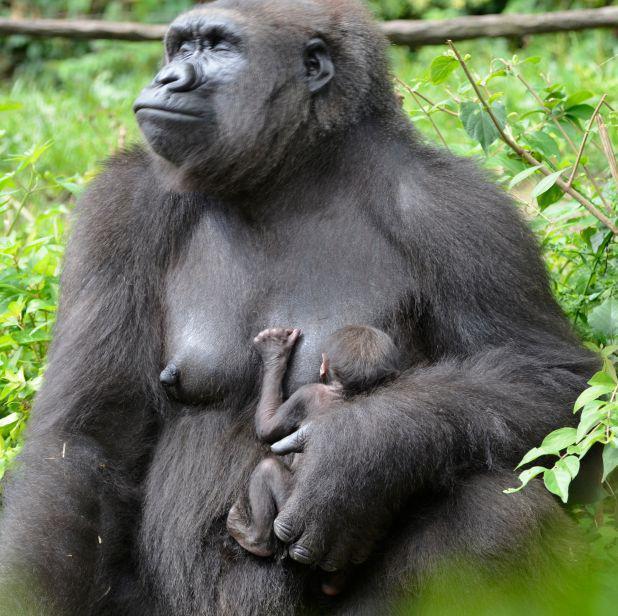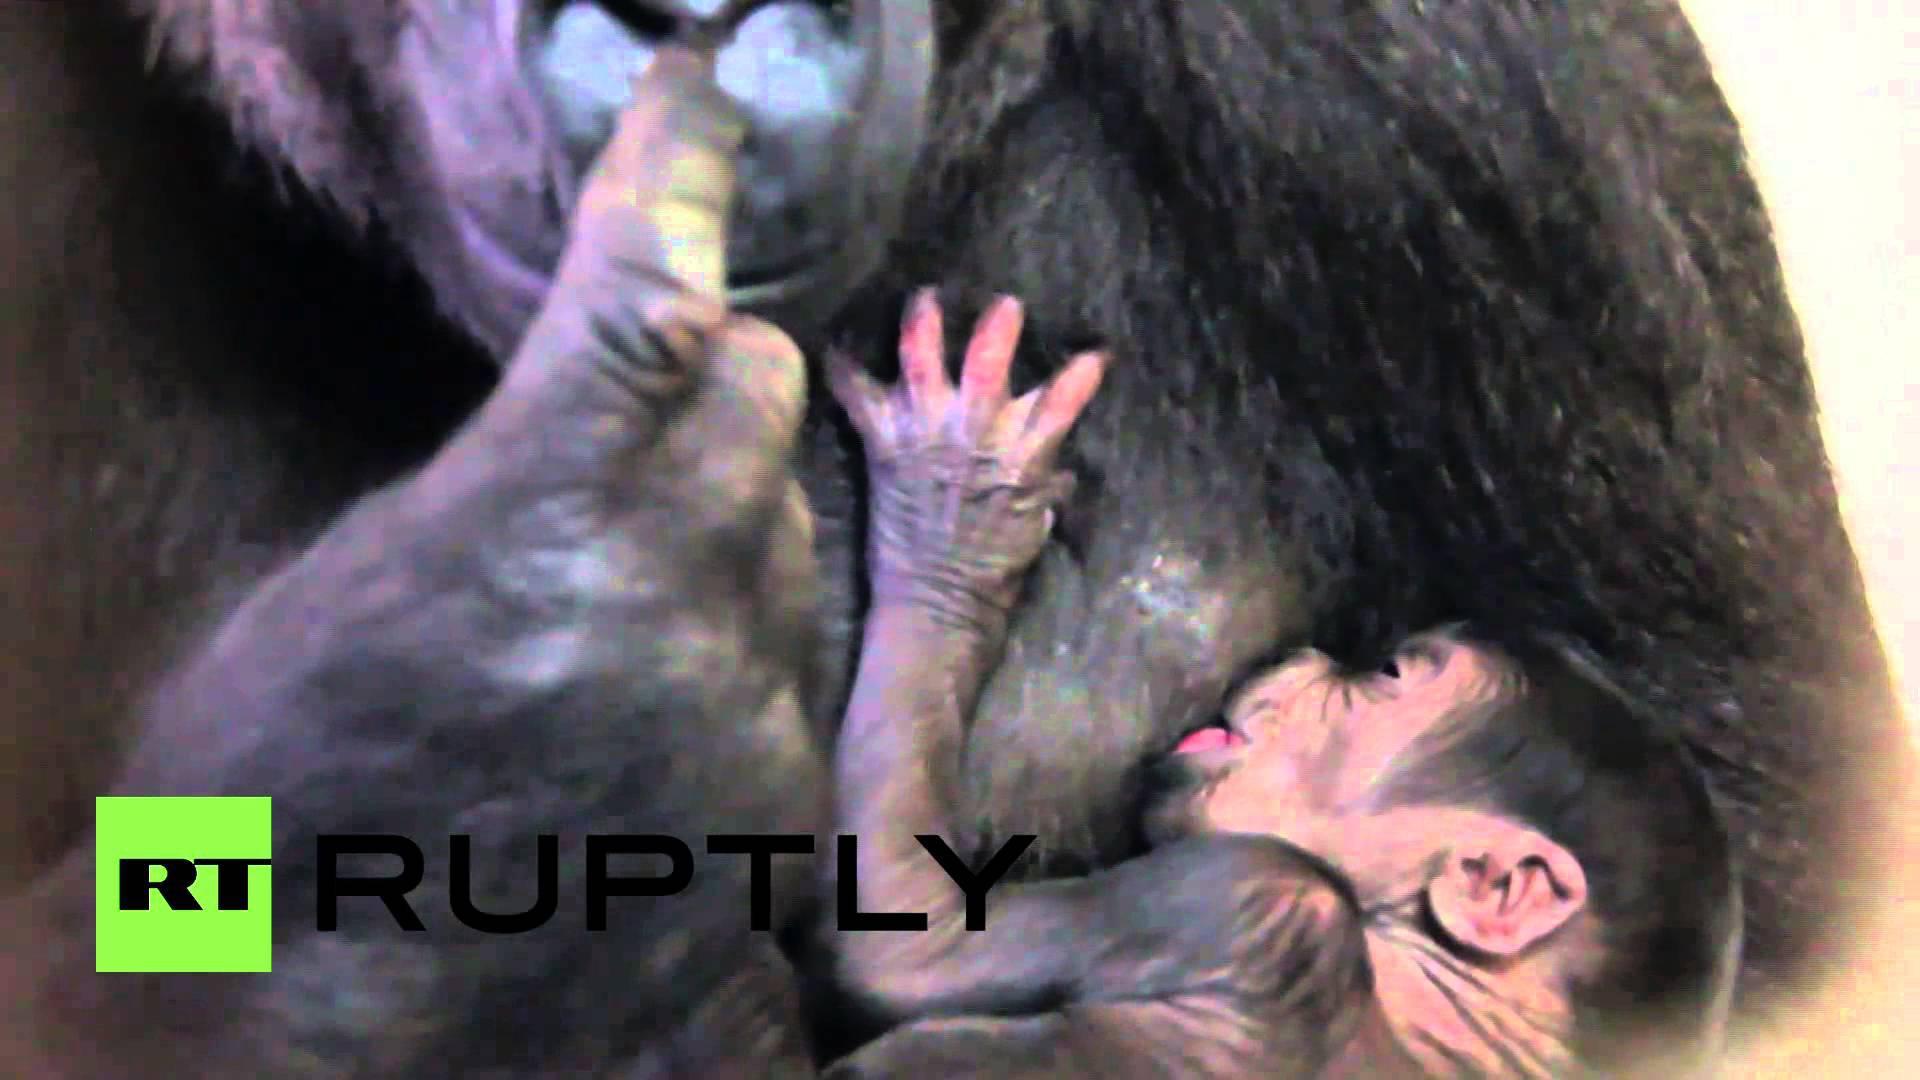The first image is the image on the left, the second image is the image on the right. For the images displayed, is the sentence "Each image shows a baby ape nursing at its mother's breast." factually correct? Answer yes or no. Yes. The first image is the image on the left, the second image is the image on the right. Examine the images to the left and right. Is the description "a gorilla is sitting in the grass holding her infant" accurate? Answer yes or no. Yes. 